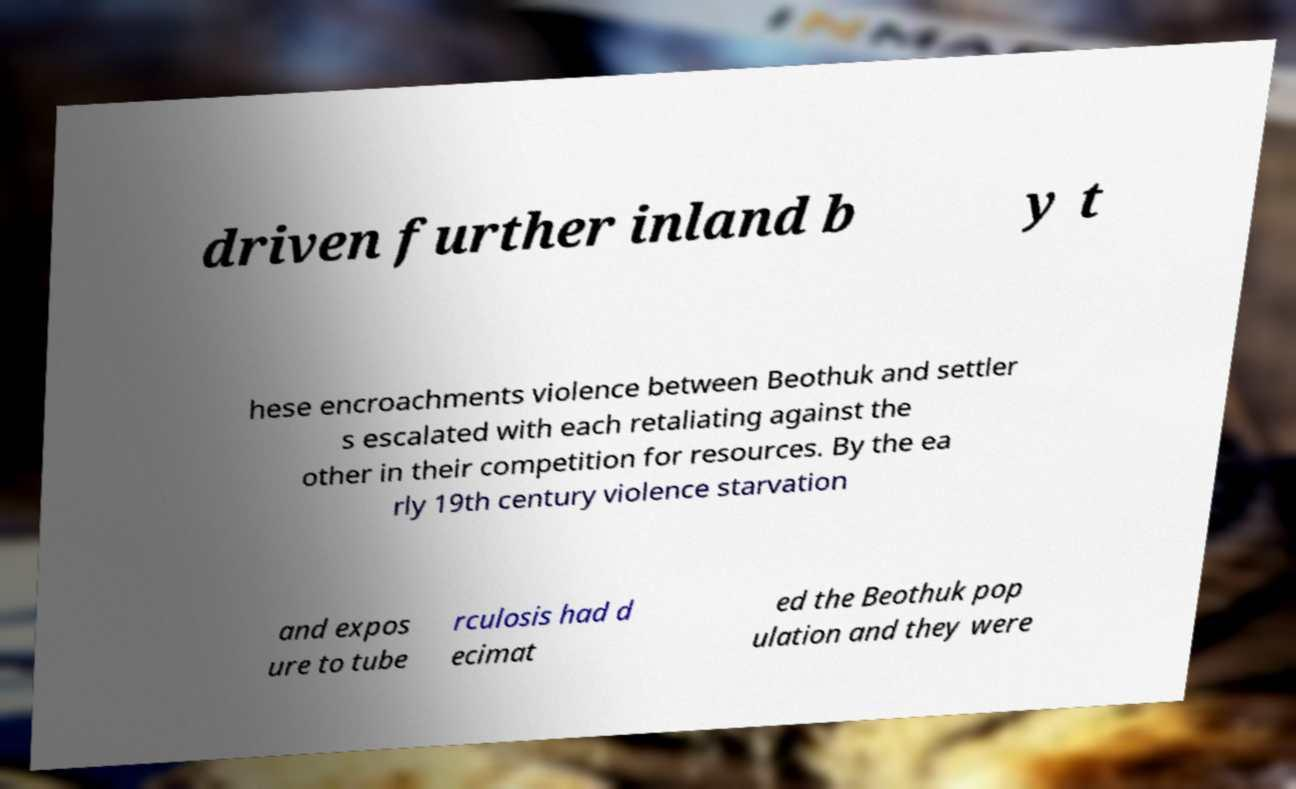I need the written content from this picture converted into text. Can you do that? driven further inland b y t hese encroachments violence between Beothuk and settler s escalated with each retaliating against the other in their competition for resources. By the ea rly 19th century violence starvation and expos ure to tube rculosis had d ecimat ed the Beothuk pop ulation and they were 